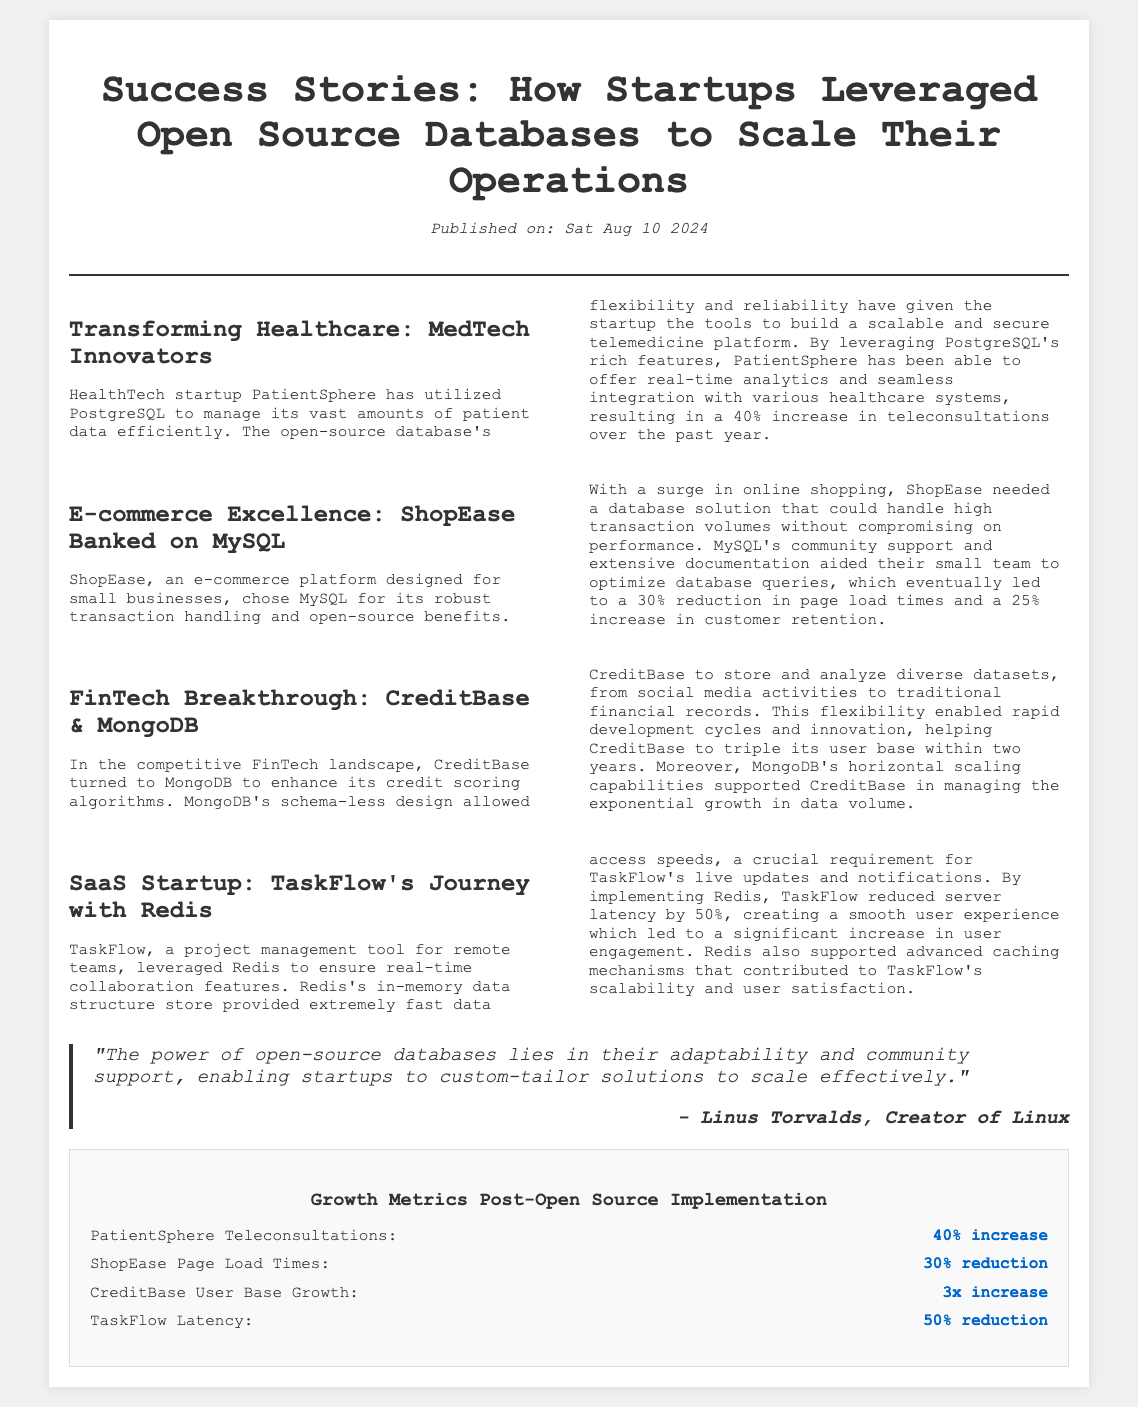what is the name of the healthcare startup mentioned? The document states that the healthcare startup is called PatientSphere.
Answer: PatientSphere which database did ShopEase use? According to the document, ShopEase chose MySQL as their database solution.
Answer: MySQL what was the percentage increase in teleconsultations for PatientSphere? The document notes a 40% increase in teleconsultations for PatientSphere.
Answer: 40% who is quoted in the document? The document quotes Linus Torvalds, the creator of Linux.
Answer: Linus Torvalds what was CreditBase's user base growth factor? The document indicates that CreditBase tripled its user base within two years, which is a growth factor of 3.
Answer: 3 how much did TaskFlow reduce server latency by? The document mentions that TaskFlow reduced server latency by 50%.
Answer: 50% what type of design does MongoDB utilize? The document states that MongoDB has a schema-less design.
Answer: schema-less what feature of Redis was crucial for TaskFlow? The document highlights that fast data access speeds were crucial for TaskFlow's real-time collaboration features.
Answer: fast data access speeds what visual element summarizes growth metrics? The document includes an infographic that summarizes the growth metrics post-open-source implementation.
Answer: infographic 